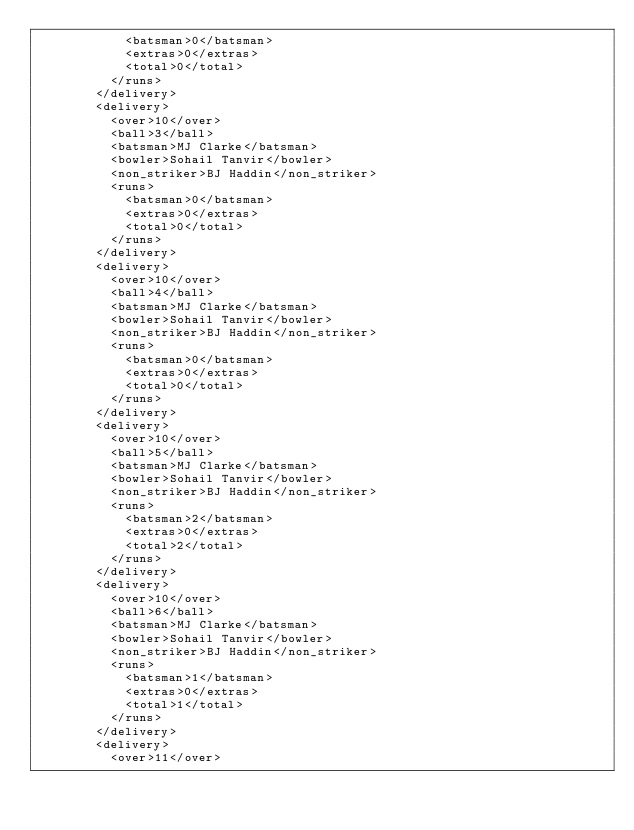Convert code to text. <code><loc_0><loc_0><loc_500><loc_500><_XML_>            <batsman>0</batsman>
            <extras>0</extras>
            <total>0</total>
          </runs>
        </delivery>
        <delivery>
          <over>10</over>
          <ball>3</ball>
          <batsman>MJ Clarke</batsman>
          <bowler>Sohail Tanvir</bowler>
          <non_striker>BJ Haddin</non_striker>
          <runs>
            <batsman>0</batsman>
            <extras>0</extras>
            <total>0</total>
          </runs>
        </delivery>
        <delivery>
          <over>10</over>
          <ball>4</ball>
          <batsman>MJ Clarke</batsman>
          <bowler>Sohail Tanvir</bowler>
          <non_striker>BJ Haddin</non_striker>
          <runs>
            <batsman>0</batsman>
            <extras>0</extras>
            <total>0</total>
          </runs>
        </delivery>
        <delivery>
          <over>10</over>
          <ball>5</ball>
          <batsman>MJ Clarke</batsman>
          <bowler>Sohail Tanvir</bowler>
          <non_striker>BJ Haddin</non_striker>
          <runs>
            <batsman>2</batsman>
            <extras>0</extras>
            <total>2</total>
          </runs>
        </delivery>
        <delivery>
          <over>10</over>
          <ball>6</ball>
          <batsman>MJ Clarke</batsman>
          <bowler>Sohail Tanvir</bowler>
          <non_striker>BJ Haddin</non_striker>
          <runs>
            <batsman>1</batsman>
            <extras>0</extras>
            <total>1</total>
          </runs>
        </delivery>
        <delivery>
          <over>11</over></code> 